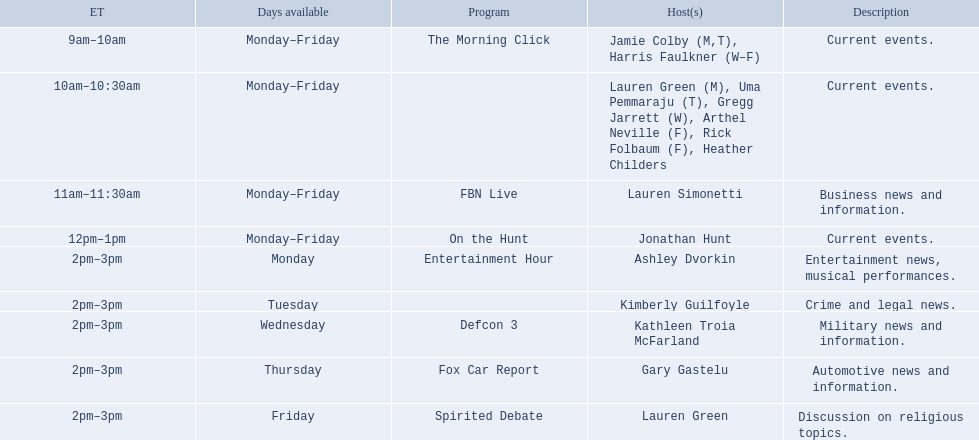What are the names of every host? Jamie Colby (M,T), Harris Faulkner (W–F), Lauren Green (M), Uma Pemmaraju (T), Gregg Jarrett (W), Arthel Neville (F), Rick Folbaum (F), Heather Childers, Lauren Simonetti, Jonathan Hunt, Ashley Dvorkin, Kimberly Guilfoyle, Kathleen Troia McFarland, Gary Gastelu, Lauren Green. Which hosts have a show scheduled on fridays? Jamie Colby (M,T), Harris Faulkner (W–F), Lauren Green (M), Uma Pemmaraju (T), Gregg Jarrett (W), Arthel Neville (F), Rick Folbaum (F), Heather Childers, Lauren Simonetti, Jonathan Hunt, Lauren Green. Among these hosts, who has friday as their only availability? Lauren Green. 